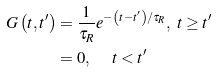Convert formula to latex. <formula><loc_0><loc_0><loc_500><loc_500>G \left ( t , t ^ { \prime } \right ) & = \frac { 1 } { \tau _ { R } } e ^ { - \left ( t - t ^ { \prime } \right ) / \tau _ { R } } , \ t \geq t ^ { \prime } \\ & = 0 , \quad \ t < t ^ { \prime }</formula> 